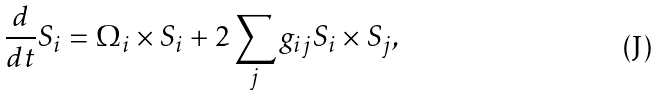Convert formula to latex. <formula><loc_0><loc_0><loc_500><loc_500>\frac { d } { d t } S _ { i } = \Omega _ { i } \times S _ { i } + 2 \sum _ { j } g _ { i j } S _ { i } \times S _ { j } ,</formula> 